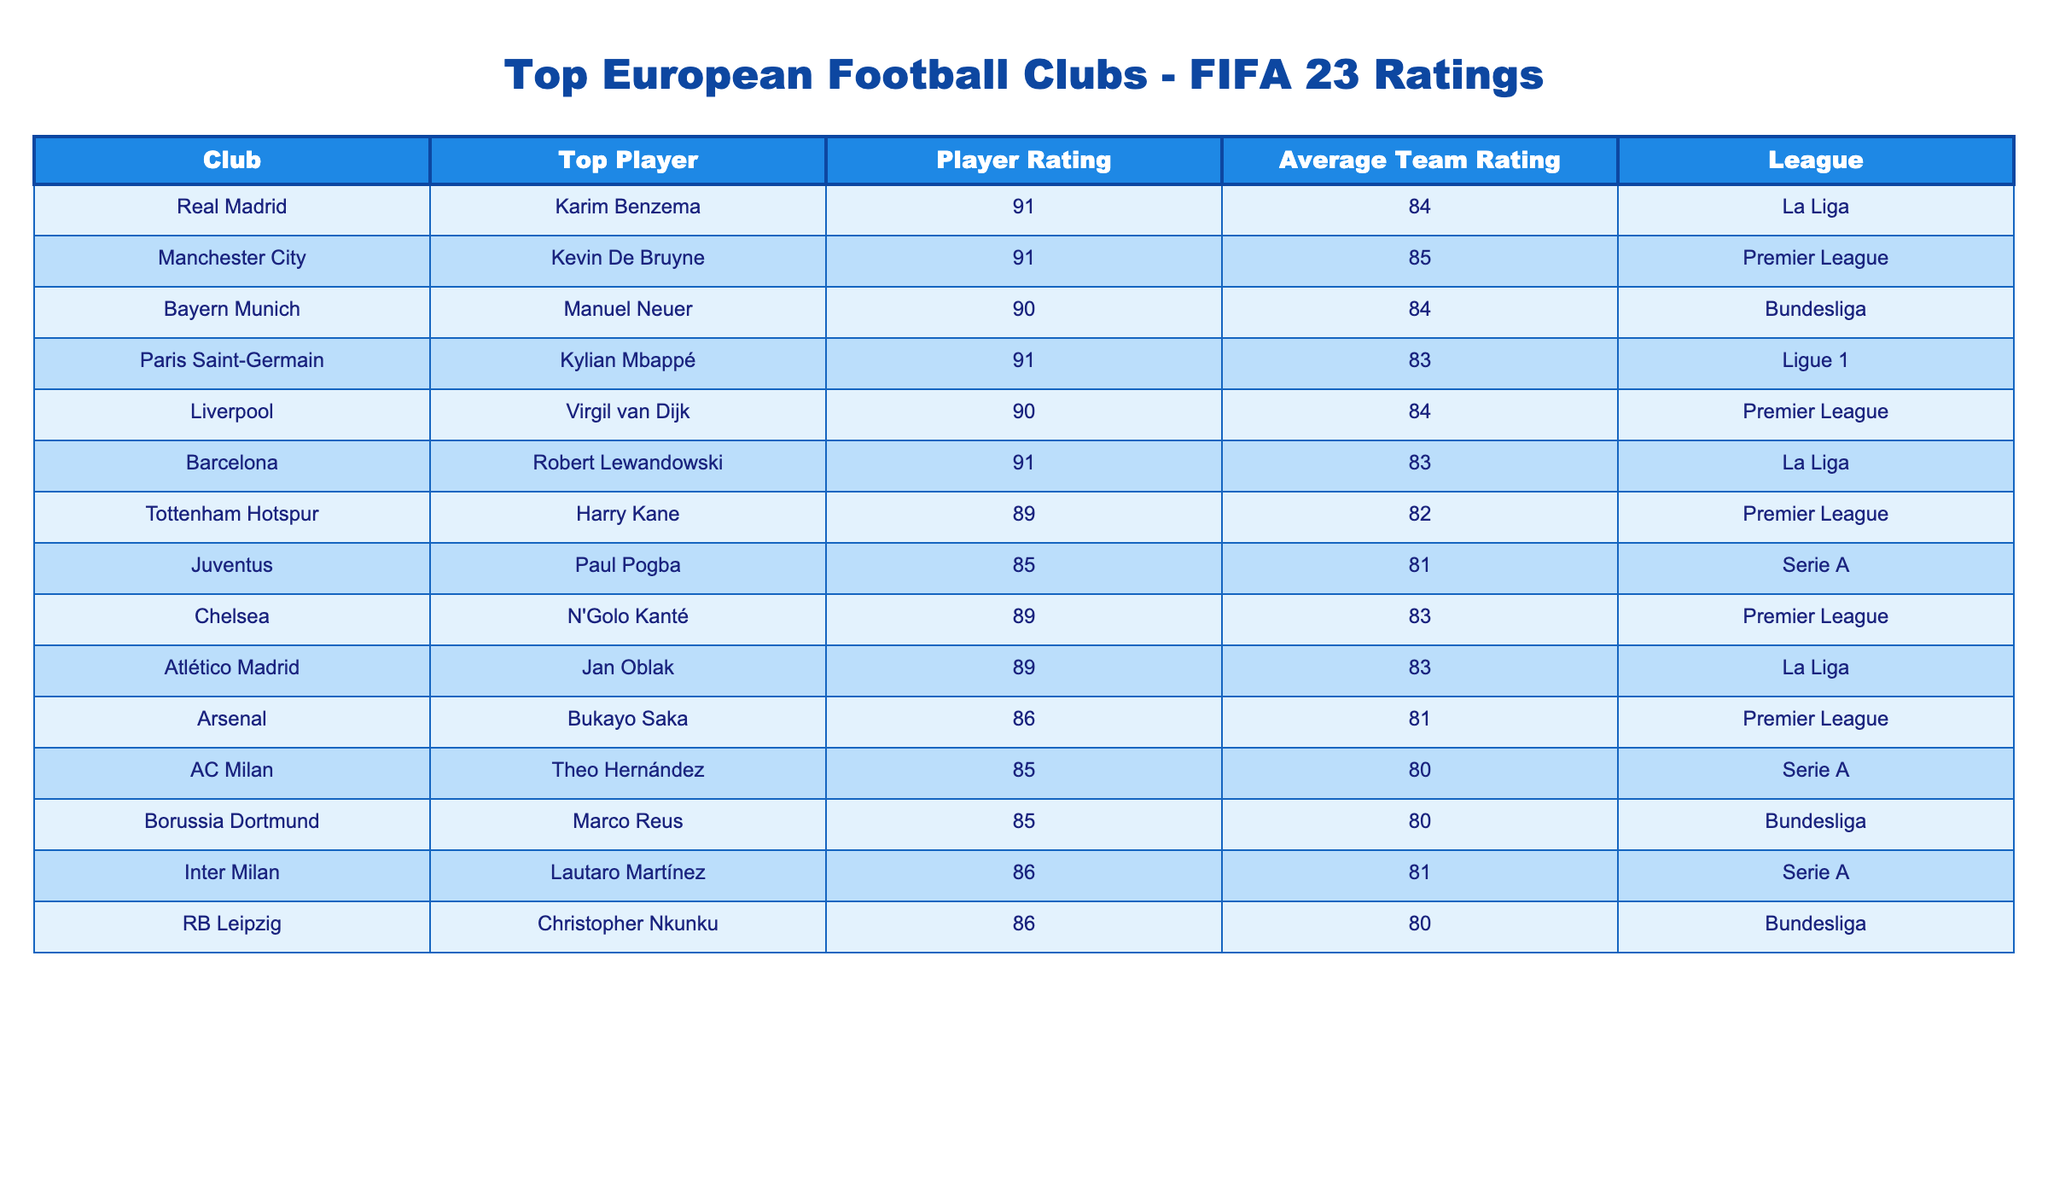What is the player rating of Kylian Mbappé? According to the table, Kylian Mbappé, who plays for Paris Saint-Germain, has a player rating of 91.
Answer: 91 Which club has the highest average team rating? Manchester City has the highest average team rating of 85. Comparing the average ratings across all clubs in the table confirms this.
Answer: Manchester City Does Liverpool have a player rated above 90? No, the highest player rating in Liverpool is 90, which belongs to Virgil van Dijk, so there is no player rated above 90.
Answer: No How many players from La Liga have a rating of 91? There are two players from La Liga rated 91, namely Karim Benzema from Real Madrid and Robert Lewandowski from Barcelona. Counting the relevant entries confirms this.
Answer: 2 What is the difference between the highest and lowest player ratings in the table? The highest player ratings are 91 (Benzema, Mbappé, and Lewandowski) and the lowest is 85 (Pogba, Hernández, and Reus), which means the difference is 91 - 85 = 6.
Answer: 6 Is the average team rating of Bundesliga clubs higher than that of Serie A clubs? The Bundesliga's average rating is (84 + 80 + 80) / 3 = 81.33, and Serie A's average rating is (81 + 80 + 81) / 3 = 80.67. Therefore, the average for Bundesliga is higher.
Answer: Yes How many players have a rating of 89 or higher? There are five players with ratings of 89 or higher: Benzema (91), Mbappé (91), Lewandowski (91), De Bruyne (91), and Neuer (90). Summing these players gives us a total of five.
Answer: 5 Which player is the top-rated for Chelsea? The top-rated player for Chelsea is N'Golo Kanté, whose rating is 89, as per the table data.
Answer: N'Golo Kanté What is the average player rating of the Premier League clubs listed? The Premier League clubs listed are Manchester City (91), Liverpool (90), Tottenham (89), Chelsea (89), and Arsenal (86). Adding these gives 91 + 90 + 89 + 89 + 86 = 445. Dividing by 5 yields the average of 89.
Answer: 89 Are there any players from Serie A with ratings above 85? Yes, Lautaro Martínez from Inter Milan is rated 86 which is above 85, and the other two players, Pogba and Hernández, are both rated 85. Thus, there are players above 85.
Answer: Yes 